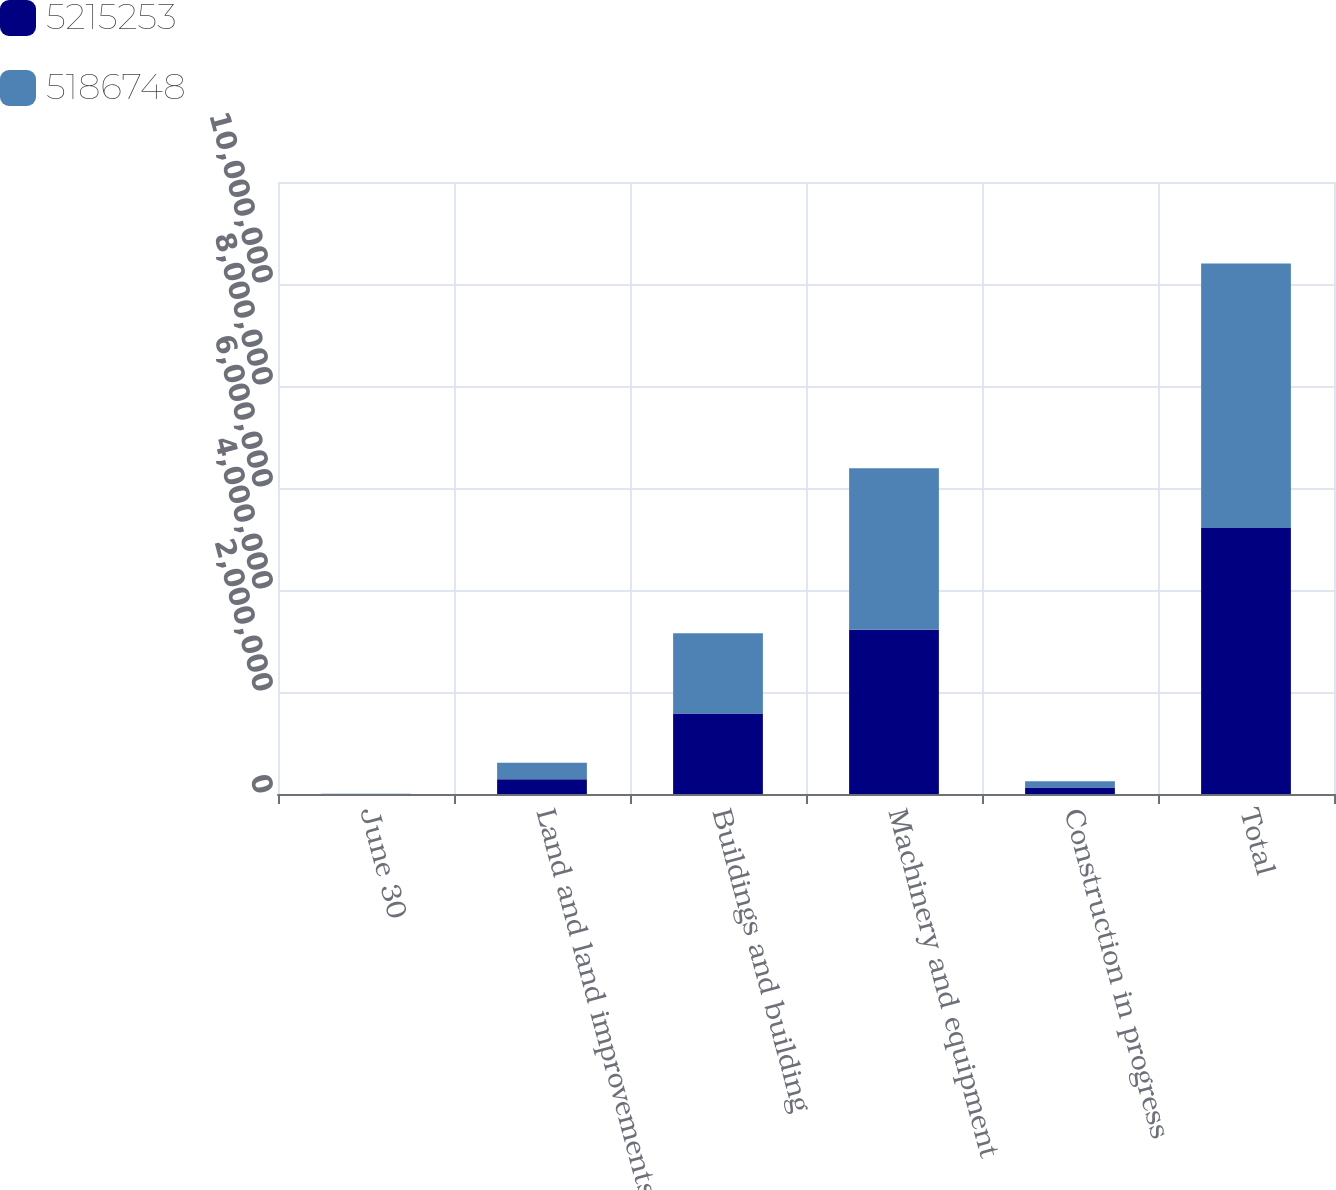Convert chart to OTSL. <chart><loc_0><loc_0><loc_500><loc_500><stacked_bar_chart><ecel><fcel>June 30<fcel>Land and land improvements<fcel>Buildings and building<fcel>Machinery and equipment<fcel>Construction in progress<fcel>Total<nl><fcel>5.21525e+06<fcel>2018<fcel>289686<fcel>1.5787e+06<fcel>3.21864e+06<fcel>128227<fcel>5.21525e+06<nl><fcel>5.18675e+06<fcel>2017<fcel>321331<fcel>1.57546e+06<fcel>3.16788e+06<fcel>122068<fcel>5.18675e+06<nl></chart> 